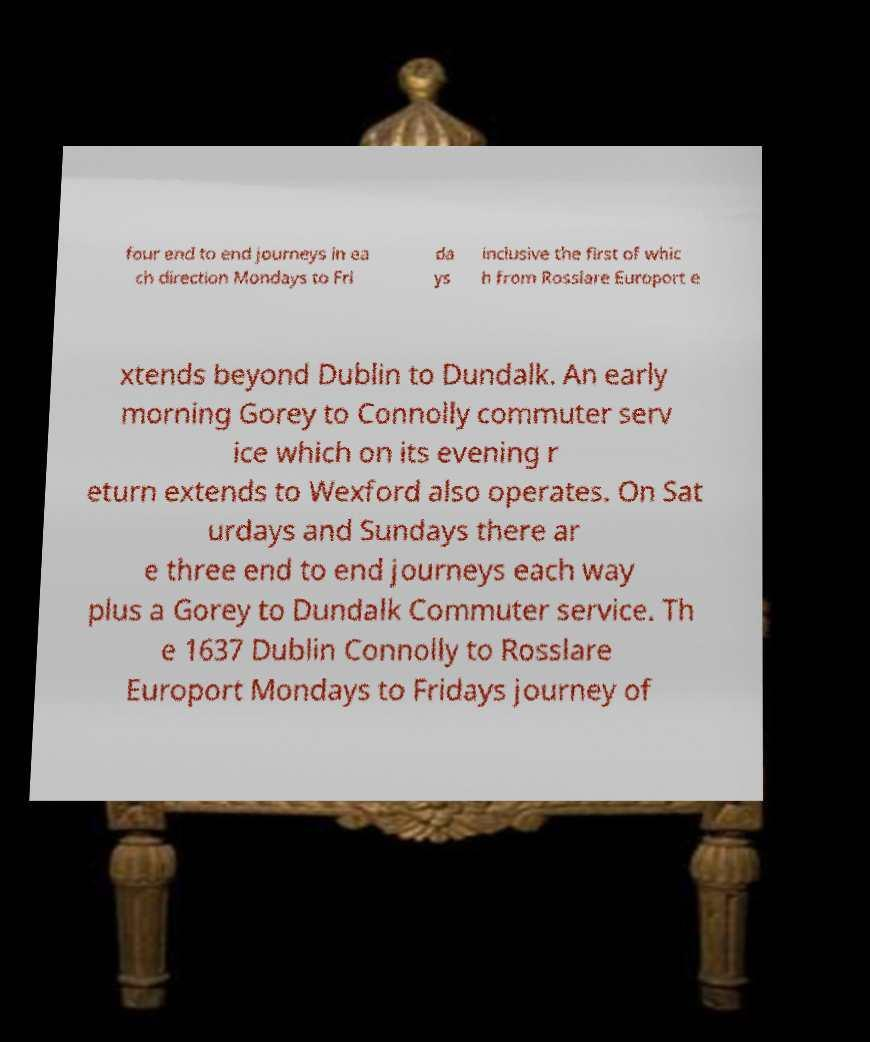Could you assist in decoding the text presented in this image and type it out clearly? four end to end journeys in ea ch direction Mondays to Fri da ys inclusive the first of whic h from Rosslare Europort e xtends beyond Dublin to Dundalk. An early morning Gorey to Connolly commuter serv ice which on its evening r eturn extends to Wexford also operates. On Sat urdays and Sundays there ar e three end to end journeys each way plus a Gorey to Dundalk Commuter service. Th e 1637 Dublin Connolly to Rosslare Europort Mondays to Fridays journey of 